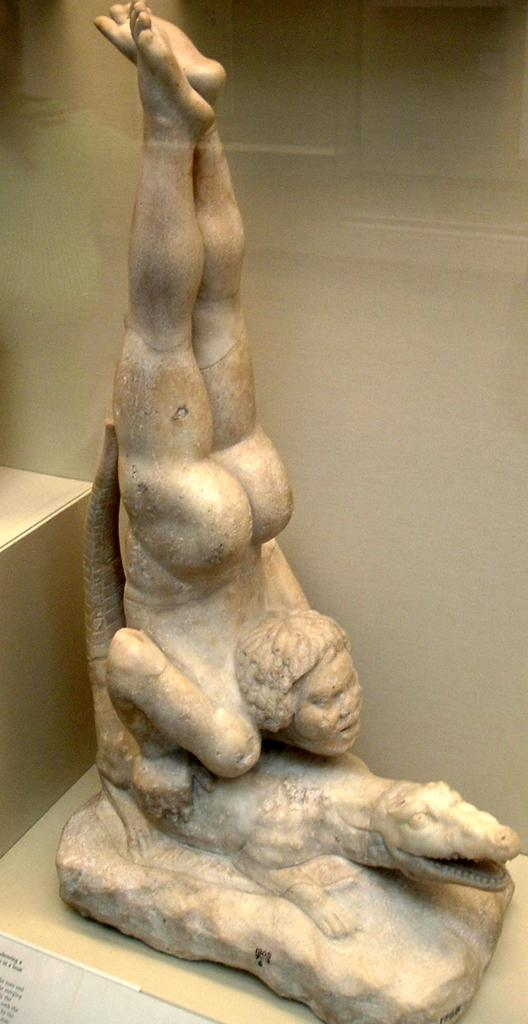What type of sculptures can be seen in the image? There is a sculpture of a person and a sculpture of a crocodile in the image. What is the surface on which the sculptures are placed? The sculptures are on a creamy surface. Is there any text visible in the image? Yes, there is a text visible on a paper in the bottom left of the image. What type of crime is being committed by the stick in the image? There is no stick or crime present in the image. What type of art is being created by the sculptures in the image? The provided facts do not mention the type of art or the artist, so we cannot determine the type of art being created by the sculptures in the image. 